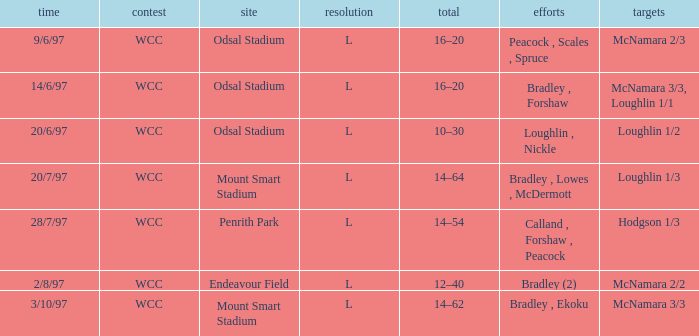What was the score on 20/6/97? 10–30. 